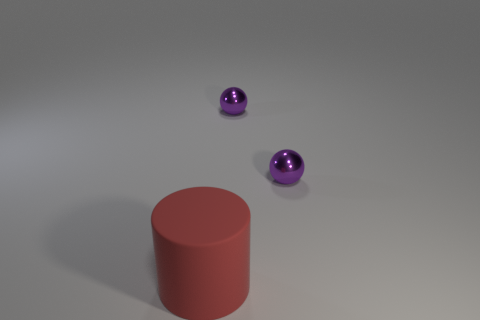What number of objects are purple things or things behind the big matte cylinder?
Make the answer very short. 2. Are there any large purple cylinders made of the same material as the red thing?
Ensure brevity in your answer.  No. Are there any red things in front of the cylinder?
Ensure brevity in your answer.  No. Are there fewer matte cylinders than purple objects?
Offer a terse response. Yes. How many other objects are there of the same color as the matte cylinder?
Your response must be concise. 0. How many tiny green metallic cubes are there?
Give a very brief answer. 0. Are there fewer shiny balls on the left side of the large matte cylinder than big blue cubes?
Your response must be concise. No. What is the size of the matte cylinder?
Your response must be concise. Large. What number of yellow things are small shiny spheres or matte things?
Your answer should be very brief. 0. What number of other things are the same size as the rubber object?
Give a very brief answer. 0. 